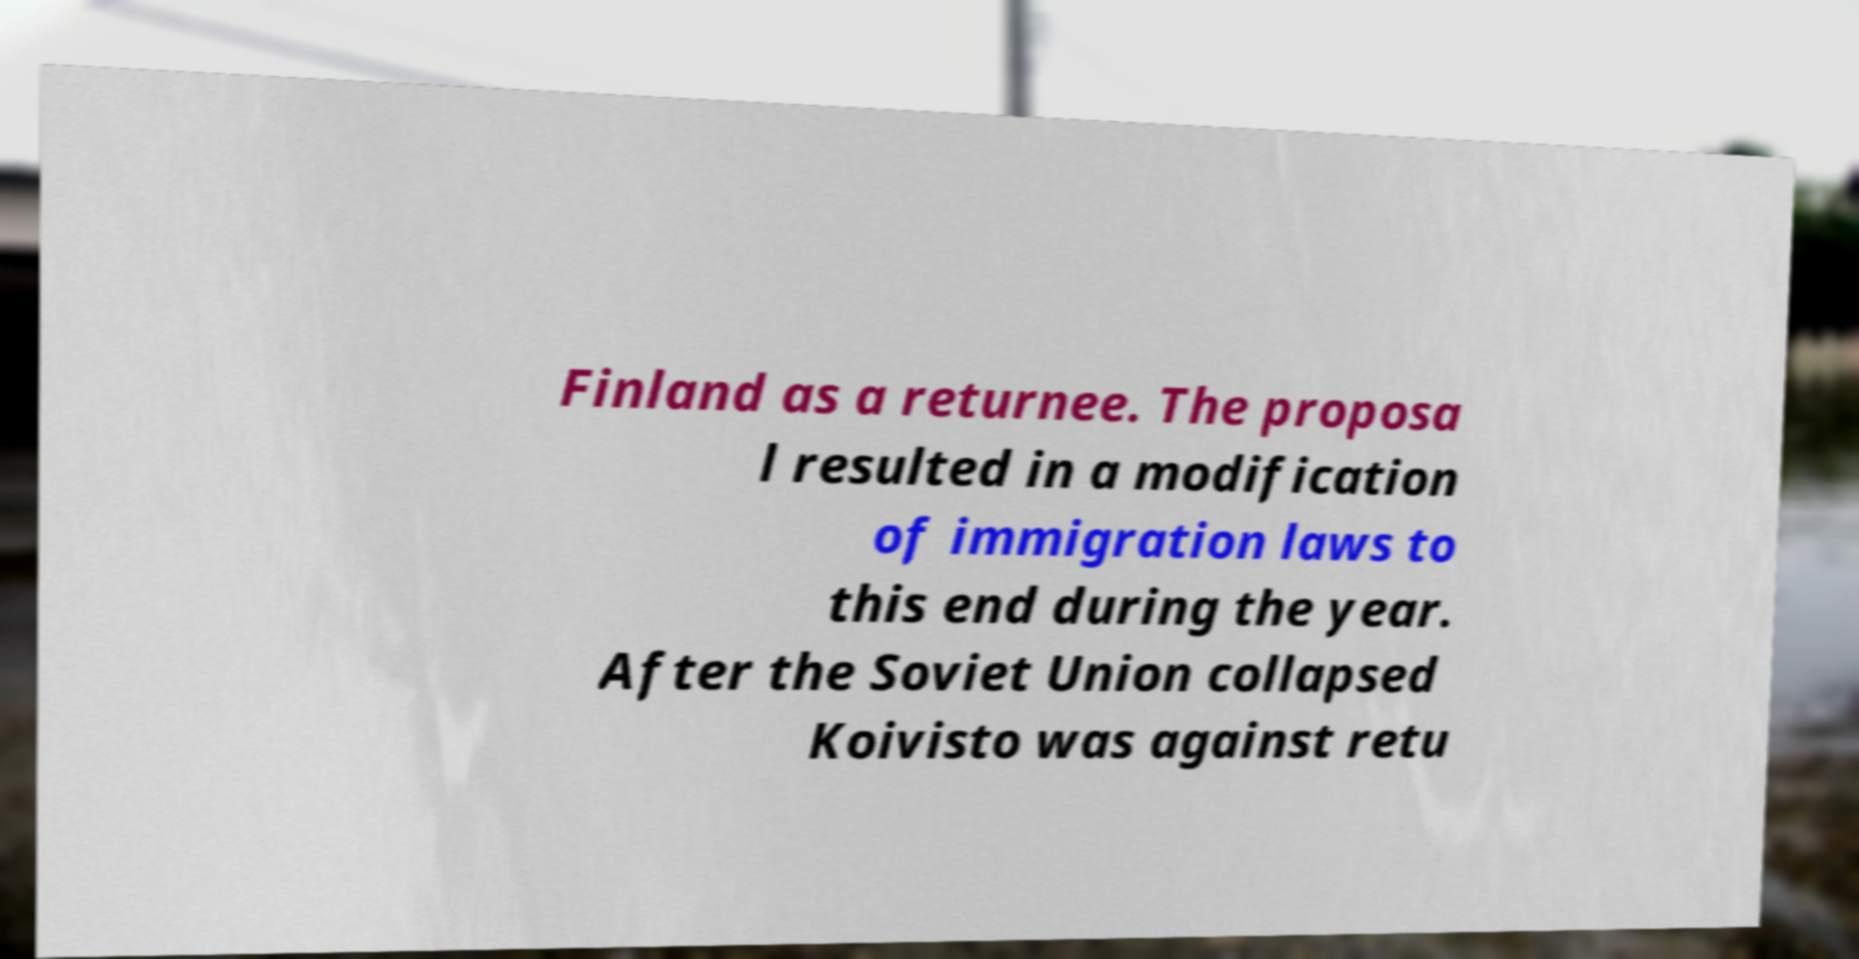Please read and relay the text visible in this image. What does it say? Finland as a returnee. The proposa l resulted in a modification of immigration laws to this end during the year. After the Soviet Union collapsed Koivisto was against retu 